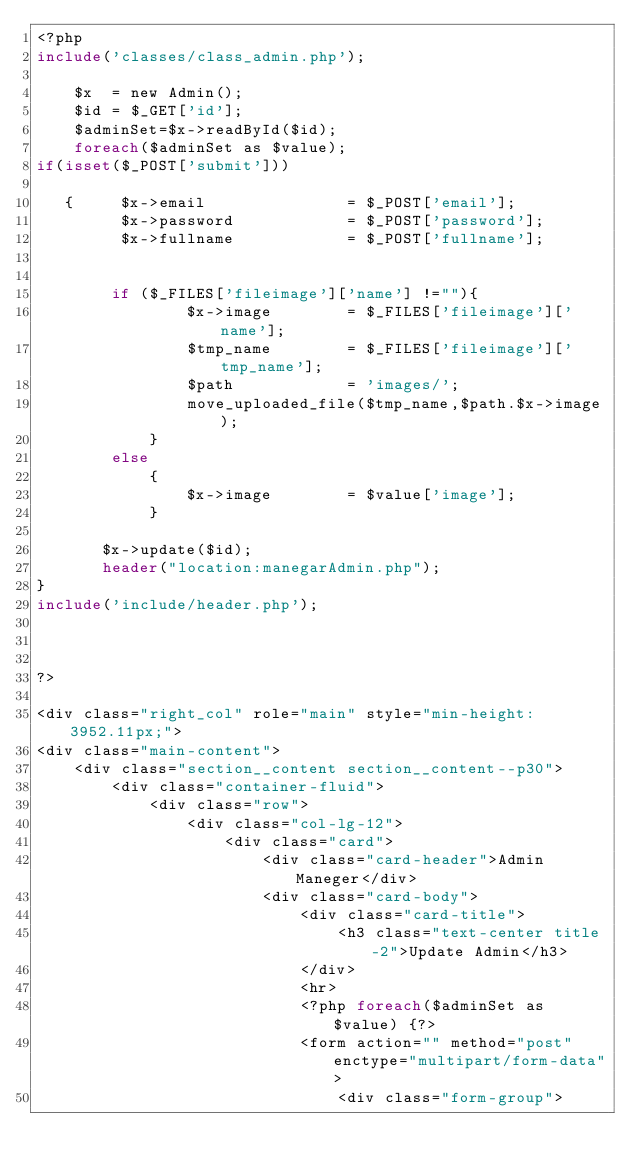Convert code to text. <code><loc_0><loc_0><loc_500><loc_500><_PHP_><?php
include('classes/class_admin.php');

    $x  = new Admin();
    $id = $_GET['id'];
    $adminSet=$x->readById($id);
    foreach($adminSet as $value);
if(isset($_POST['submit']))

   {     $x->email               = $_POST['email'];
         $x->password            = $_POST['password'];
         $x->fullname            = $_POST['fullname'];
      

        if ($_FILES['fileimage']['name'] !=""){
                $x->image        = $_FILES['fileimage']['name'];
                $tmp_name        = $_FILES['fileimage']['tmp_name'];
                $path            = 'images/';
                move_uploaded_file($tmp_name,$path.$x->image);
            }
        else
            {
                $x->image        = $value['image'];
            }

       $x->update($id);
       header("location:manegarAdmin.php");   
}
include('include/header.php');



?>

<div class="right_col" role="main" style="min-height: 3952.11px;">
<div class="main-content">
    <div class="section__content section__content--p30">
        <div class="container-fluid">
            <div class="row">
                <div class="col-lg-12">
                    <div class="card">
                        <div class="card-header">Admin Maneger</div>
                        <div class="card-body">
                            <div class="card-title">
                                <h3 class="text-center title-2">Update Admin</h3>
                            </div>
                            <hr>
                            <?php foreach($adminSet as $value) {?>
                            <form action="" method="post" enctype="multipart/form-data">
                                <div class="form-group"></code> 